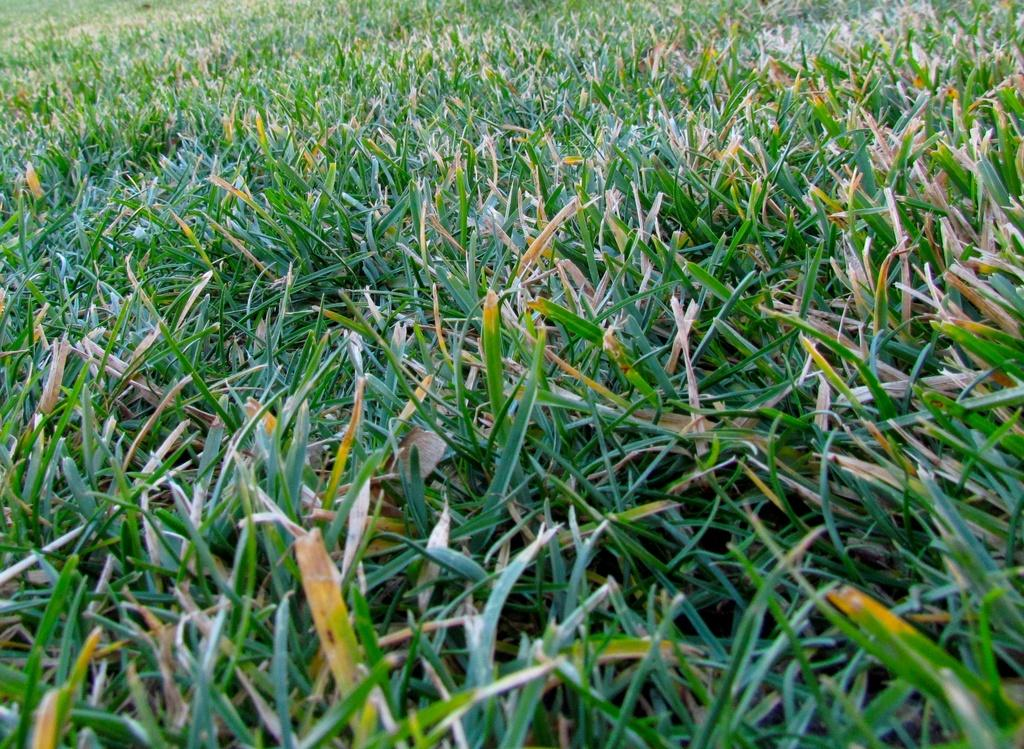What type of vegetation is visible in the image? There is green color grass in the image. Can you see a hen swimming in fear in the image? There is no hen or any swimming or fear-related activity present in the image; it only features green color grass. 